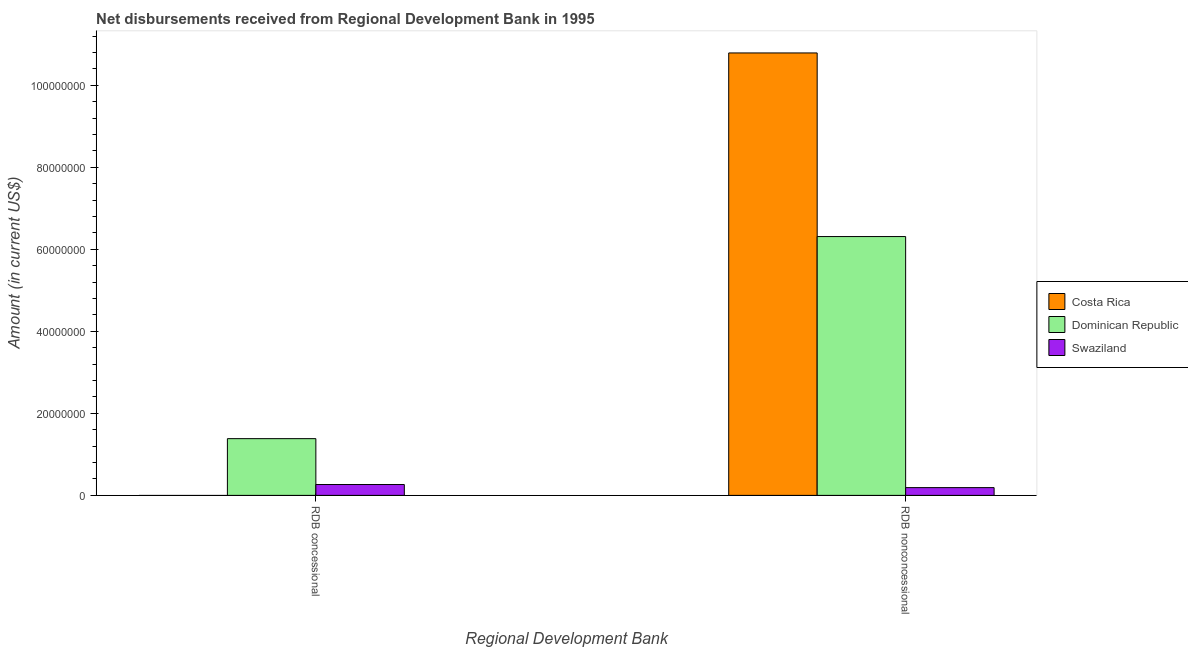How many different coloured bars are there?
Offer a terse response. 3. Are the number of bars per tick equal to the number of legend labels?
Your response must be concise. No. Are the number of bars on each tick of the X-axis equal?
Keep it short and to the point. No. How many bars are there on the 2nd tick from the left?
Keep it short and to the point. 3. What is the label of the 2nd group of bars from the left?
Your answer should be very brief. RDB nonconcessional. What is the net non concessional disbursements from rdb in Dominican Republic?
Offer a terse response. 6.31e+07. Across all countries, what is the maximum net non concessional disbursements from rdb?
Offer a very short reply. 1.08e+08. Across all countries, what is the minimum net non concessional disbursements from rdb?
Your answer should be very brief. 1.89e+06. What is the total net concessional disbursements from rdb in the graph?
Your answer should be compact. 1.65e+07. What is the difference between the net non concessional disbursements from rdb in Swaziland and that in Dominican Republic?
Your answer should be very brief. -6.12e+07. What is the difference between the net concessional disbursements from rdb in Costa Rica and the net non concessional disbursements from rdb in Swaziland?
Provide a succinct answer. -1.89e+06. What is the average net non concessional disbursements from rdb per country?
Offer a terse response. 5.76e+07. What is the difference between the net concessional disbursements from rdb and net non concessional disbursements from rdb in Dominican Republic?
Your answer should be very brief. -4.93e+07. What is the ratio of the net non concessional disbursements from rdb in Dominican Republic to that in Swaziland?
Give a very brief answer. 33.34. How many legend labels are there?
Give a very brief answer. 3. What is the title of the graph?
Provide a short and direct response. Net disbursements received from Regional Development Bank in 1995. What is the label or title of the X-axis?
Your answer should be very brief. Regional Development Bank. What is the label or title of the Y-axis?
Your response must be concise. Amount (in current US$). What is the Amount (in current US$) in Dominican Republic in RDB concessional?
Offer a very short reply. 1.38e+07. What is the Amount (in current US$) in Swaziland in RDB concessional?
Make the answer very short. 2.65e+06. What is the Amount (in current US$) in Costa Rica in RDB nonconcessional?
Offer a terse response. 1.08e+08. What is the Amount (in current US$) in Dominican Republic in RDB nonconcessional?
Provide a short and direct response. 6.31e+07. What is the Amount (in current US$) in Swaziland in RDB nonconcessional?
Offer a very short reply. 1.89e+06. Across all Regional Development Bank, what is the maximum Amount (in current US$) of Costa Rica?
Give a very brief answer. 1.08e+08. Across all Regional Development Bank, what is the maximum Amount (in current US$) in Dominican Republic?
Your answer should be compact. 6.31e+07. Across all Regional Development Bank, what is the maximum Amount (in current US$) of Swaziland?
Provide a succinct answer. 2.65e+06. Across all Regional Development Bank, what is the minimum Amount (in current US$) of Dominican Republic?
Provide a short and direct response. 1.38e+07. Across all Regional Development Bank, what is the minimum Amount (in current US$) of Swaziland?
Your answer should be very brief. 1.89e+06. What is the total Amount (in current US$) of Costa Rica in the graph?
Your answer should be very brief. 1.08e+08. What is the total Amount (in current US$) of Dominican Republic in the graph?
Offer a very short reply. 7.69e+07. What is the total Amount (in current US$) in Swaziland in the graph?
Keep it short and to the point. 4.54e+06. What is the difference between the Amount (in current US$) in Dominican Republic in RDB concessional and that in RDB nonconcessional?
Offer a very short reply. -4.93e+07. What is the difference between the Amount (in current US$) in Swaziland in RDB concessional and that in RDB nonconcessional?
Provide a short and direct response. 7.57e+05. What is the difference between the Amount (in current US$) in Dominican Republic in RDB concessional and the Amount (in current US$) in Swaziland in RDB nonconcessional?
Provide a succinct answer. 1.19e+07. What is the average Amount (in current US$) of Costa Rica per Regional Development Bank?
Provide a short and direct response. 5.39e+07. What is the average Amount (in current US$) of Dominican Republic per Regional Development Bank?
Your response must be concise. 3.85e+07. What is the average Amount (in current US$) of Swaziland per Regional Development Bank?
Provide a short and direct response. 2.27e+06. What is the difference between the Amount (in current US$) of Dominican Republic and Amount (in current US$) of Swaziland in RDB concessional?
Provide a short and direct response. 1.12e+07. What is the difference between the Amount (in current US$) in Costa Rica and Amount (in current US$) in Dominican Republic in RDB nonconcessional?
Offer a terse response. 4.48e+07. What is the difference between the Amount (in current US$) in Costa Rica and Amount (in current US$) in Swaziland in RDB nonconcessional?
Your answer should be very brief. 1.06e+08. What is the difference between the Amount (in current US$) of Dominican Republic and Amount (in current US$) of Swaziland in RDB nonconcessional?
Ensure brevity in your answer.  6.12e+07. What is the ratio of the Amount (in current US$) in Dominican Republic in RDB concessional to that in RDB nonconcessional?
Make the answer very short. 0.22. What is the ratio of the Amount (in current US$) of Swaziland in RDB concessional to that in RDB nonconcessional?
Give a very brief answer. 1.4. What is the difference between the highest and the second highest Amount (in current US$) in Dominican Republic?
Make the answer very short. 4.93e+07. What is the difference between the highest and the second highest Amount (in current US$) in Swaziland?
Your response must be concise. 7.57e+05. What is the difference between the highest and the lowest Amount (in current US$) in Costa Rica?
Provide a succinct answer. 1.08e+08. What is the difference between the highest and the lowest Amount (in current US$) of Dominican Republic?
Give a very brief answer. 4.93e+07. What is the difference between the highest and the lowest Amount (in current US$) of Swaziland?
Provide a succinct answer. 7.57e+05. 